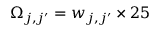<formula> <loc_0><loc_0><loc_500><loc_500>\Omega _ { j , j ^ { \prime } } = w _ { j , j ^ { \prime } } \times 2 5</formula> 